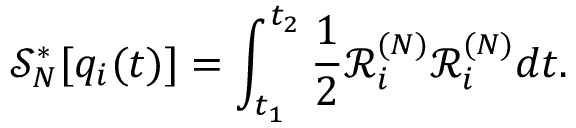<formula> <loc_0><loc_0><loc_500><loc_500>\mathcal { S } _ { N } ^ { * } [ q _ { i } ( t ) ] = \int _ { t _ { 1 } } ^ { t _ { 2 } } \frac { 1 } { 2 } \mathcal { R } _ { i } ^ { ( N ) } \mathcal { R } _ { i } ^ { ( N ) } d t .</formula> 